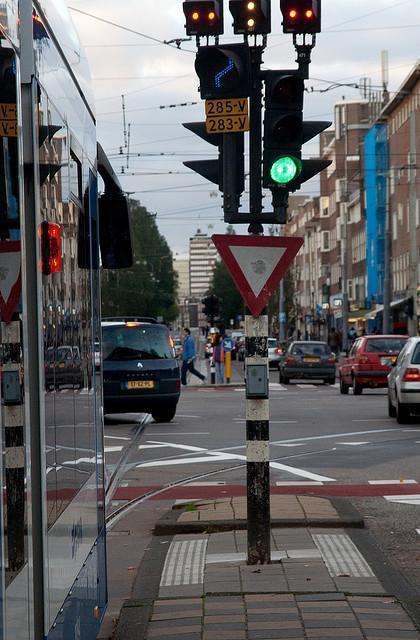How many cars are there?
Give a very brief answer. 3. How many bikes are there?
Give a very brief answer. 0. 